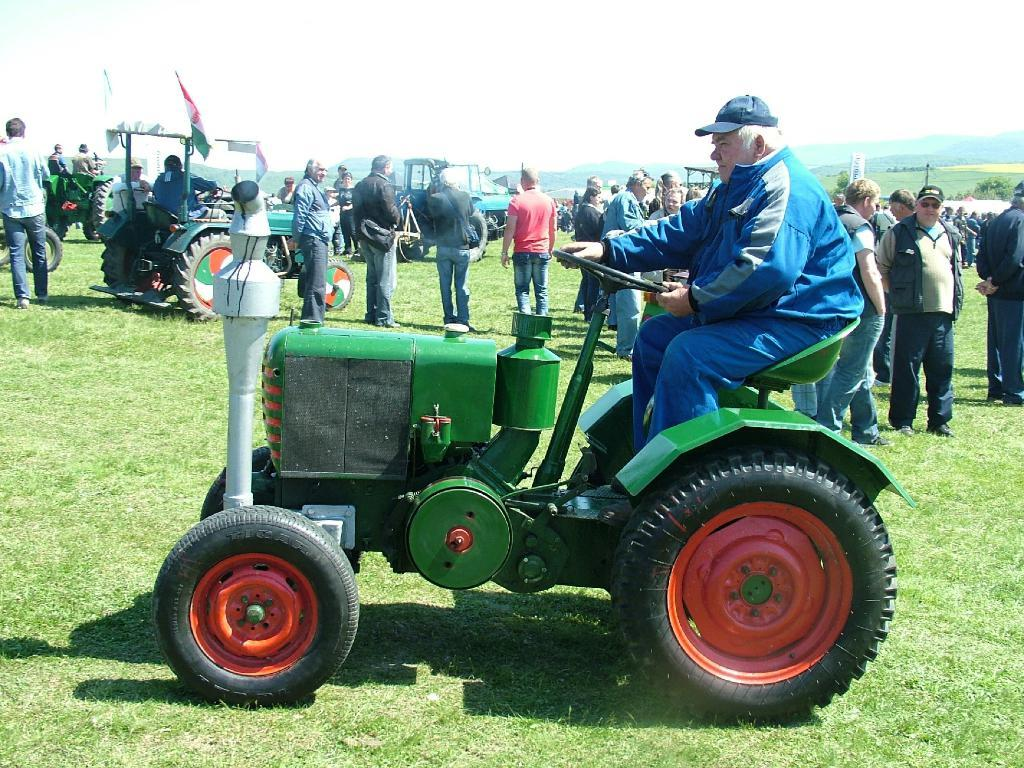How many people are in the image? There are multiple persons standing on the ground in the image. What are some of the people doing in the image? Some persons are riding on vehicles in the image. What can be seen in the background of the image? The sky is visible at the top of the image. Where are the rabbits sitting in the image? There are no rabbits present in the image. What type of grape is being used as a prop in the image? There is no grape present in the image. 